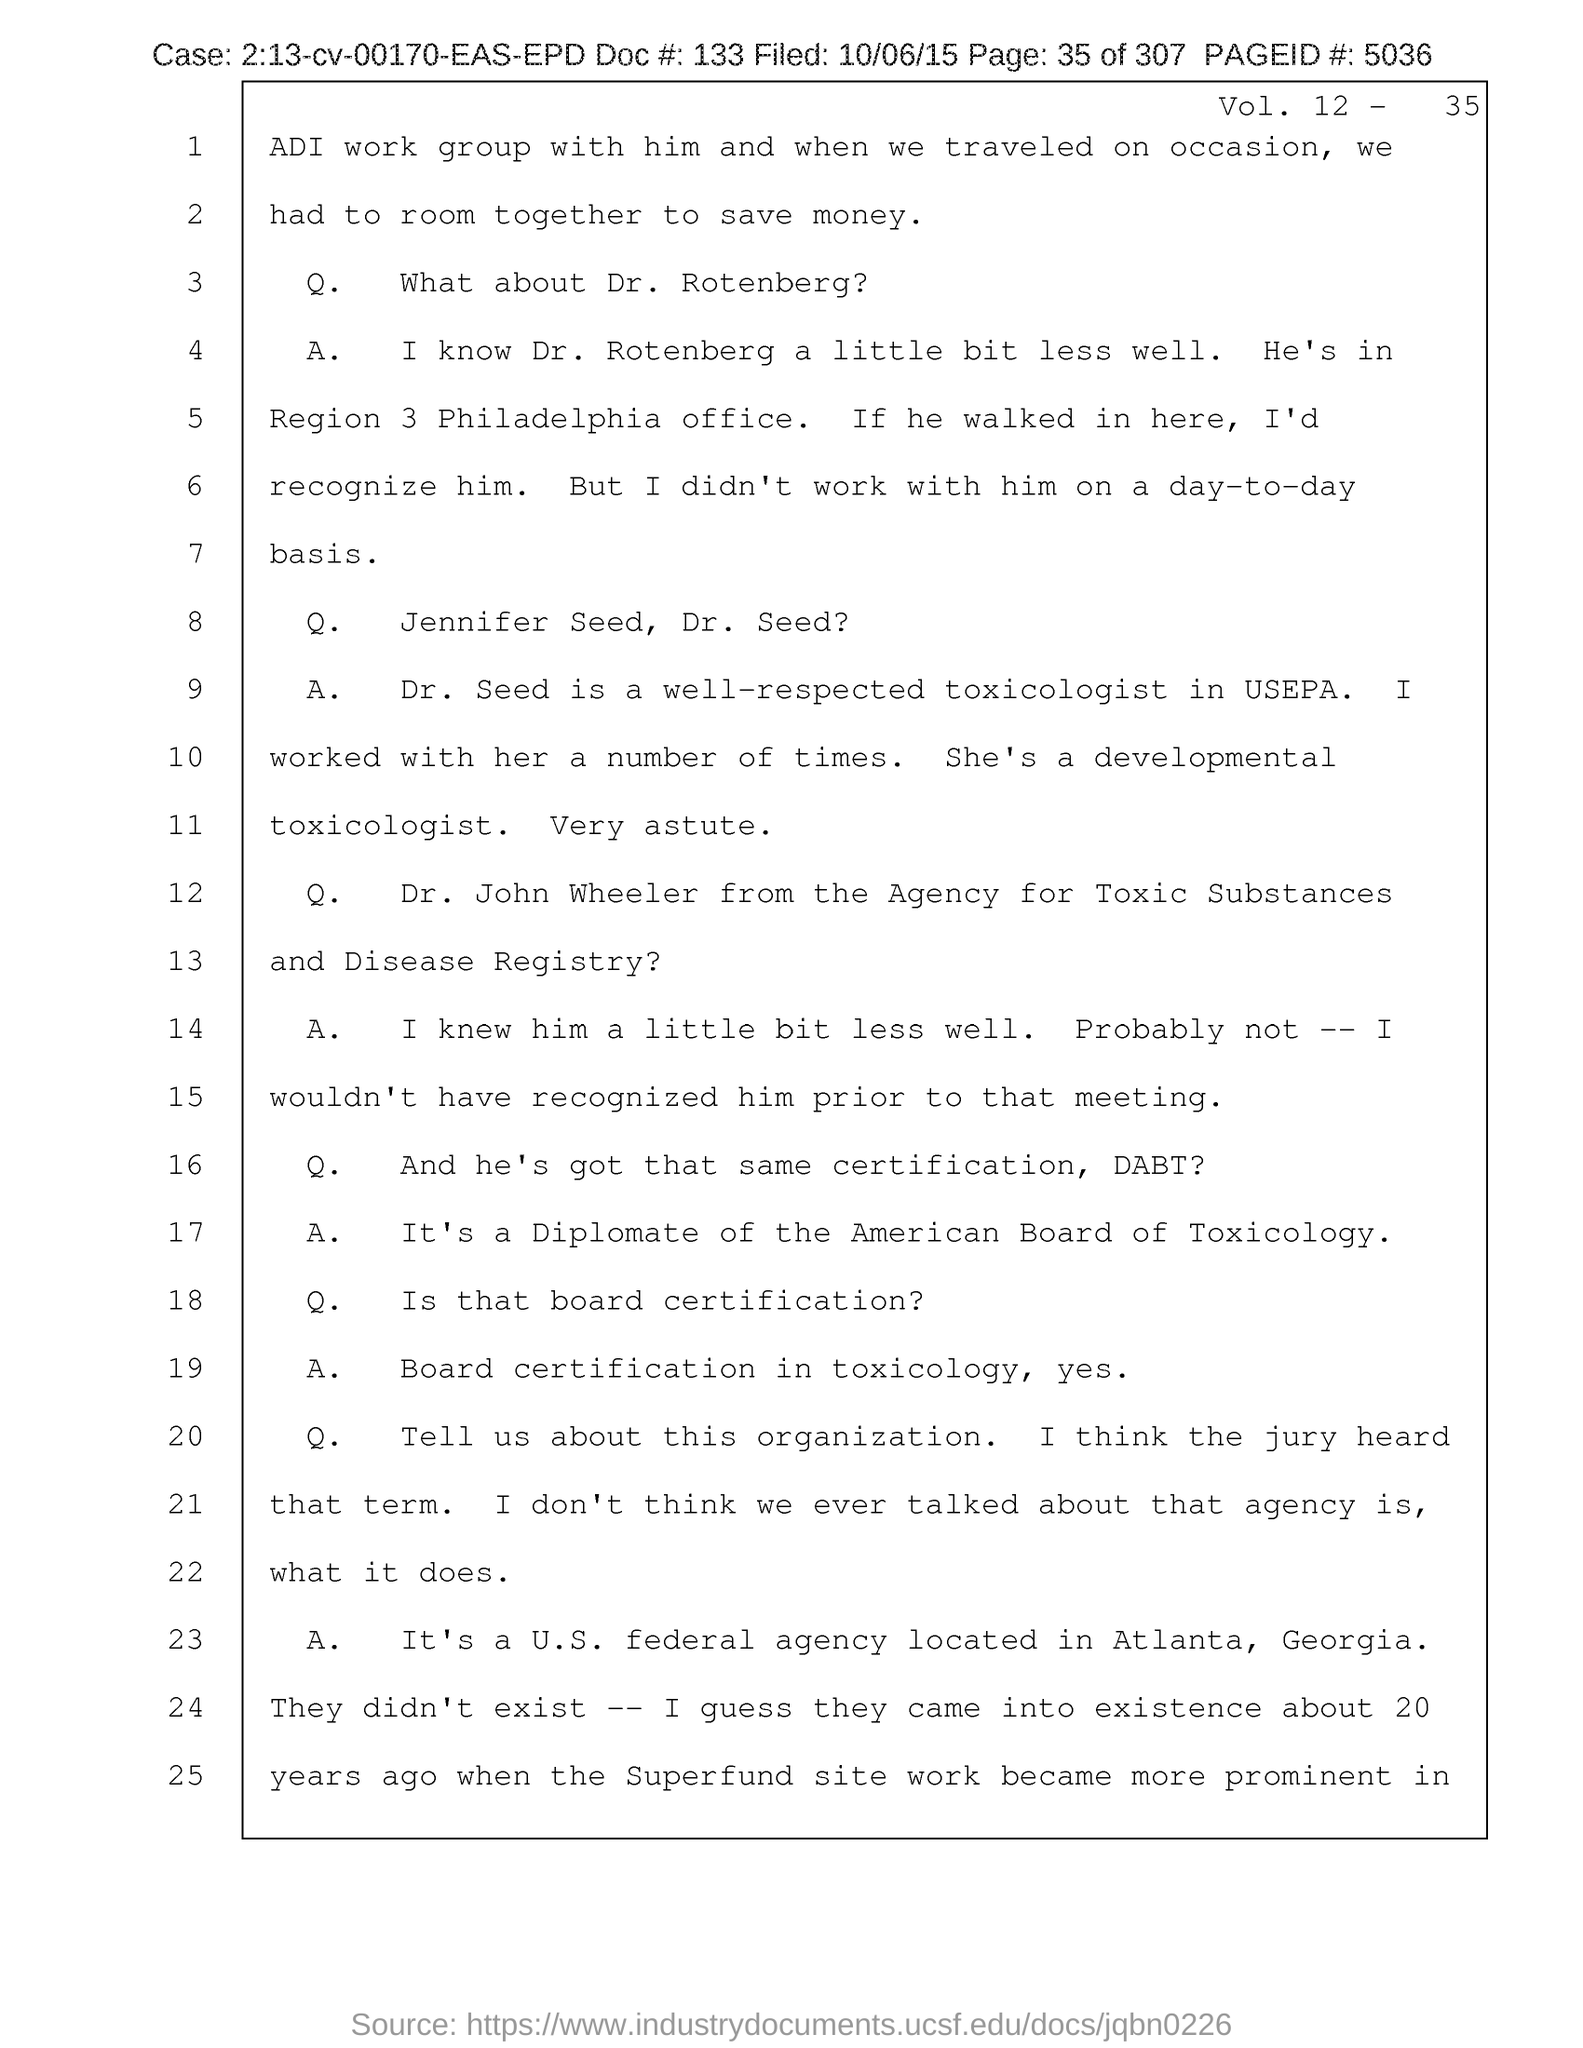What is the Vol. no. given in the document?
Ensure brevity in your answer.  12-    35. What is the page no mentioned in this document?
Keep it short and to the point. 35. What is the Page ID # mentioned in the document?
Provide a succinct answer. 5036. What is the filed date of the document?
Make the answer very short. 10/06/15. What is the doc # given in the document?
Your answer should be compact. 133. What is the case no mentioned in the document?
Offer a very short reply. 2:13-cv-00170-EAS-EPD. 